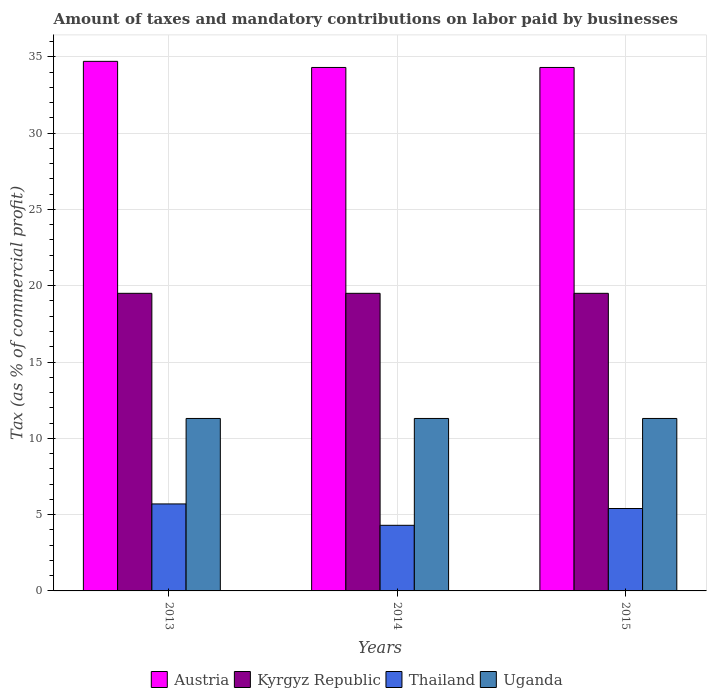Are the number of bars per tick equal to the number of legend labels?
Keep it short and to the point. Yes. How many bars are there on the 2nd tick from the right?
Give a very brief answer. 4. What is the percentage of taxes paid by businesses in Thailand in 2015?
Your answer should be very brief. 5.4. Across all years, what is the maximum percentage of taxes paid by businesses in Uganda?
Provide a succinct answer. 11.3. Across all years, what is the minimum percentage of taxes paid by businesses in Thailand?
Provide a succinct answer. 4.3. In which year was the percentage of taxes paid by businesses in Kyrgyz Republic maximum?
Make the answer very short. 2013. In which year was the percentage of taxes paid by businesses in Thailand minimum?
Your response must be concise. 2014. What is the total percentage of taxes paid by businesses in Austria in the graph?
Make the answer very short. 103.3. What is the difference between the percentage of taxes paid by businesses in Uganda in 2013 and that in 2015?
Your answer should be very brief. 0. What is the difference between the percentage of taxes paid by businesses in Austria in 2015 and the percentage of taxes paid by businesses in Uganda in 2014?
Your answer should be very brief. 23. What is the average percentage of taxes paid by businesses in Austria per year?
Give a very brief answer. 34.43. In the year 2013, what is the difference between the percentage of taxes paid by businesses in Austria and percentage of taxes paid by businesses in Uganda?
Ensure brevity in your answer.  23.4. What is the ratio of the percentage of taxes paid by businesses in Kyrgyz Republic in 2013 to that in 2015?
Offer a terse response. 1. Is the percentage of taxes paid by businesses in Uganda in 2013 less than that in 2015?
Offer a terse response. No. Is the difference between the percentage of taxes paid by businesses in Austria in 2013 and 2014 greater than the difference between the percentage of taxes paid by businesses in Uganda in 2013 and 2014?
Give a very brief answer. Yes. What is the difference between the highest and the second highest percentage of taxes paid by businesses in Thailand?
Ensure brevity in your answer.  0.3. What is the difference between the highest and the lowest percentage of taxes paid by businesses in Thailand?
Your answer should be compact. 1.4. In how many years, is the percentage of taxes paid by businesses in Uganda greater than the average percentage of taxes paid by businesses in Uganda taken over all years?
Your answer should be compact. 0. Is it the case that in every year, the sum of the percentage of taxes paid by businesses in Kyrgyz Republic and percentage of taxes paid by businesses in Austria is greater than the sum of percentage of taxes paid by businesses in Uganda and percentage of taxes paid by businesses in Thailand?
Your answer should be compact. Yes. What does the 4th bar from the left in 2014 represents?
Provide a succinct answer. Uganda. What does the 1st bar from the right in 2014 represents?
Your answer should be very brief. Uganda. Is it the case that in every year, the sum of the percentage of taxes paid by businesses in Kyrgyz Republic and percentage of taxes paid by businesses in Thailand is greater than the percentage of taxes paid by businesses in Austria?
Make the answer very short. No. How many bars are there?
Make the answer very short. 12. Are all the bars in the graph horizontal?
Provide a short and direct response. No. What is the difference between two consecutive major ticks on the Y-axis?
Keep it short and to the point. 5. Does the graph contain any zero values?
Your answer should be very brief. No. Where does the legend appear in the graph?
Your answer should be very brief. Bottom center. How many legend labels are there?
Offer a very short reply. 4. What is the title of the graph?
Your answer should be compact. Amount of taxes and mandatory contributions on labor paid by businesses. What is the label or title of the X-axis?
Your response must be concise. Years. What is the label or title of the Y-axis?
Offer a very short reply. Tax (as % of commercial profit). What is the Tax (as % of commercial profit) of Austria in 2013?
Give a very brief answer. 34.7. What is the Tax (as % of commercial profit) in Kyrgyz Republic in 2013?
Your answer should be very brief. 19.5. What is the Tax (as % of commercial profit) in Uganda in 2013?
Your answer should be very brief. 11.3. What is the Tax (as % of commercial profit) of Austria in 2014?
Provide a succinct answer. 34.3. What is the Tax (as % of commercial profit) in Thailand in 2014?
Your answer should be very brief. 4.3. What is the Tax (as % of commercial profit) of Uganda in 2014?
Your answer should be very brief. 11.3. What is the Tax (as % of commercial profit) in Austria in 2015?
Offer a terse response. 34.3. Across all years, what is the maximum Tax (as % of commercial profit) of Austria?
Your answer should be compact. 34.7. Across all years, what is the maximum Tax (as % of commercial profit) of Thailand?
Your answer should be compact. 5.7. Across all years, what is the minimum Tax (as % of commercial profit) of Austria?
Your answer should be compact. 34.3. Across all years, what is the minimum Tax (as % of commercial profit) in Thailand?
Offer a terse response. 4.3. Across all years, what is the minimum Tax (as % of commercial profit) of Uganda?
Your answer should be compact. 11.3. What is the total Tax (as % of commercial profit) in Austria in the graph?
Offer a very short reply. 103.3. What is the total Tax (as % of commercial profit) of Kyrgyz Republic in the graph?
Make the answer very short. 58.5. What is the total Tax (as % of commercial profit) in Thailand in the graph?
Provide a short and direct response. 15.4. What is the total Tax (as % of commercial profit) in Uganda in the graph?
Offer a very short reply. 33.9. What is the difference between the Tax (as % of commercial profit) of Austria in 2013 and that in 2014?
Offer a very short reply. 0.4. What is the difference between the Tax (as % of commercial profit) in Kyrgyz Republic in 2013 and that in 2014?
Offer a very short reply. 0. What is the difference between the Tax (as % of commercial profit) in Thailand in 2013 and that in 2014?
Ensure brevity in your answer.  1.4. What is the difference between the Tax (as % of commercial profit) of Uganda in 2013 and that in 2014?
Your answer should be very brief. 0. What is the difference between the Tax (as % of commercial profit) of Austria in 2013 and that in 2015?
Offer a terse response. 0.4. What is the difference between the Tax (as % of commercial profit) of Kyrgyz Republic in 2013 and that in 2015?
Your answer should be very brief. 0. What is the difference between the Tax (as % of commercial profit) in Uganda in 2013 and that in 2015?
Offer a very short reply. 0. What is the difference between the Tax (as % of commercial profit) of Austria in 2014 and that in 2015?
Offer a very short reply. 0. What is the difference between the Tax (as % of commercial profit) in Kyrgyz Republic in 2014 and that in 2015?
Provide a succinct answer. 0. What is the difference between the Tax (as % of commercial profit) of Thailand in 2014 and that in 2015?
Make the answer very short. -1.1. What is the difference between the Tax (as % of commercial profit) of Austria in 2013 and the Tax (as % of commercial profit) of Thailand in 2014?
Your answer should be very brief. 30.4. What is the difference between the Tax (as % of commercial profit) in Austria in 2013 and the Tax (as % of commercial profit) in Uganda in 2014?
Provide a succinct answer. 23.4. What is the difference between the Tax (as % of commercial profit) of Kyrgyz Republic in 2013 and the Tax (as % of commercial profit) of Thailand in 2014?
Provide a succinct answer. 15.2. What is the difference between the Tax (as % of commercial profit) in Thailand in 2013 and the Tax (as % of commercial profit) in Uganda in 2014?
Provide a short and direct response. -5.6. What is the difference between the Tax (as % of commercial profit) of Austria in 2013 and the Tax (as % of commercial profit) of Thailand in 2015?
Provide a succinct answer. 29.3. What is the difference between the Tax (as % of commercial profit) in Austria in 2013 and the Tax (as % of commercial profit) in Uganda in 2015?
Keep it short and to the point. 23.4. What is the difference between the Tax (as % of commercial profit) of Kyrgyz Republic in 2013 and the Tax (as % of commercial profit) of Thailand in 2015?
Offer a terse response. 14.1. What is the difference between the Tax (as % of commercial profit) in Kyrgyz Republic in 2013 and the Tax (as % of commercial profit) in Uganda in 2015?
Your response must be concise. 8.2. What is the difference between the Tax (as % of commercial profit) of Thailand in 2013 and the Tax (as % of commercial profit) of Uganda in 2015?
Provide a short and direct response. -5.6. What is the difference between the Tax (as % of commercial profit) in Austria in 2014 and the Tax (as % of commercial profit) in Kyrgyz Republic in 2015?
Your answer should be very brief. 14.8. What is the difference between the Tax (as % of commercial profit) of Austria in 2014 and the Tax (as % of commercial profit) of Thailand in 2015?
Ensure brevity in your answer.  28.9. What is the average Tax (as % of commercial profit) of Austria per year?
Keep it short and to the point. 34.43. What is the average Tax (as % of commercial profit) of Kyrgyz Republic per year?
Provide a short and direct response. 19.5. What is the average Tax (as % of commercial profit) in Thailand per year?
Ensure brevity in your answer.  5.13. In the year 2013, what is the difference between the Tax (as % of commercial profit) of Austria and Tax (as % of commercial profit) of Kyrgyz Republic?
Provide a short and direct response. 15.2. In the year 2013, what is the difference between the Tax (as % of commercial profit) of Austria and Tax (as % of commercial profit) of Uganda?
Keep it short and to the point. 23.4. In the year 2013, what is the difference between the Tax (as % of commercial profit) of Kyrgyz Republic and Tax (as % of commercial profit) of Uganda?
Your answer should be very brief. 8.2. In the year 2013, what is the difference between the Tax (as % of commercial profit) in Thailand and Tax (as % of commercial profit) in Uganda?
Provide a succinct answer. -5.6. In the year 2014, what is the difference between the Tax (as % of commercial profit) of Austria and Tax (as % of commercial profit) of Kyrgyz Republic?
Ensure brevity in your answer.  14.8. In the year 2014, what is the difference between the Tax (as % of commercial profit) in Austria and Tax (as % of commercial profit) in Uganda?
Offer a terse response. 23. In the year 2014, what is the difference between the Tax (as % of commercial profit) in Kyrgyz Republic and Tax (as % of commercial profit) in Thailand?
Make the answer very short. 15.2. In the year 2014, what is the difference between the Tax (as % of commercial profit) of Kyrgyz Republic and Tax (as % of commercial profit) of Uganda?
Your answer should be compact. 8.2. In the year 2014, what is the difference between the Tax (as % of commercial profit) of Thailand and Tax (as % of commercial profit) of Uganda?
Provide a short and direct response. -7. In the year 2015, what is the difference between the Tax (as % of commercial profit) of Austria and Tax (as % of commercial profit) of Thailand?
Keep it short and to the point. 28.9. In the year 2015, what is the difference between the Tax (as % of commercial profit) in Austria and Tax (as % of commercial profit) in Uganda?
Offer a very short reply. 23. In the year 2015, what is the difference between the Tax (as % of commercial profit) of Thailand and Tax (as % of commercial profit) of Uganda?
Your answer should be very brief. -5.9. What is the ratio of the Tax (as % of commercial profit) in Austria in 2013 to that in 2014?
Keep it short and to the point. 1.01. What is the ratio of the Tax (as % of commercial profit) in Kyrgyz Republic in 2013 to that in 2014?
Ensure brevity in your answer.  1. What is the ratio of the Tax (as % of commercial profit) in Thailand in 2013 to that in 2014?
Your response must be concise. 1.33. What is the ratio of the Tax (as % of commercial profit) of Austria in 2013 to that in 2015?
Provide a short and direct response. 1.01. What is the ratio of the Tax (as % of commercial profit) in Thailand in 2013 to that in 2015?
Provide a short and direct response. 1.06. What is the ratio of the Tax (as % of commercial profit) in Kyrgyz Republic in 2014 to that in 2015?
Your answer should be very brief. 1. What is the ratio of the Tax (as % of commercial profit) of Thailand in 2014 to that in 2015?
Ensure brevity in your answer.  0.8. What is the difference between the highest and the second highest Tax (as % of commercial profit) of Kyrgyz Republic?
Your answer should be very brief. 0. What is the difference between the highest and the second highest Tax (as % of commercial profit) of Thailand?
Ensure brevity in your answer.  0.3. What is the difference between the highest and the lowest Tax (as % of commercial profit) of Austria?
Provide a succinct answer. 0.4. What is the difference between the highest and the lowest Tax (as % of commercial profit) in Kyrgyz Republic?
Keep it short and to the point. 0. 